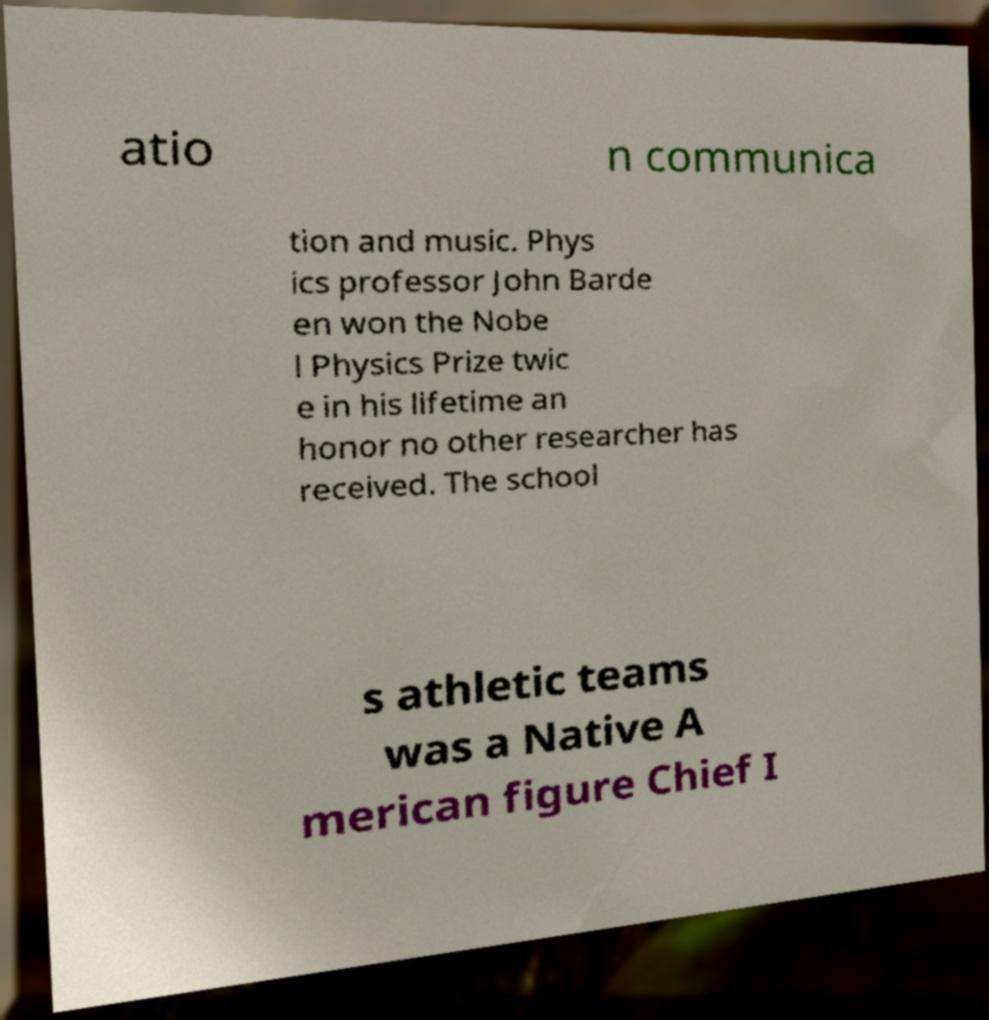For documentation purposes, I need the text within this image transcribed. Could you provide that? atio n communica tion and music. Phys ics professor John Barde en won the Nobe l Physics Prize twic e in his lifetime an honor no other researcher has received. The school s athletic teams was a Native A merican figure Chief I 